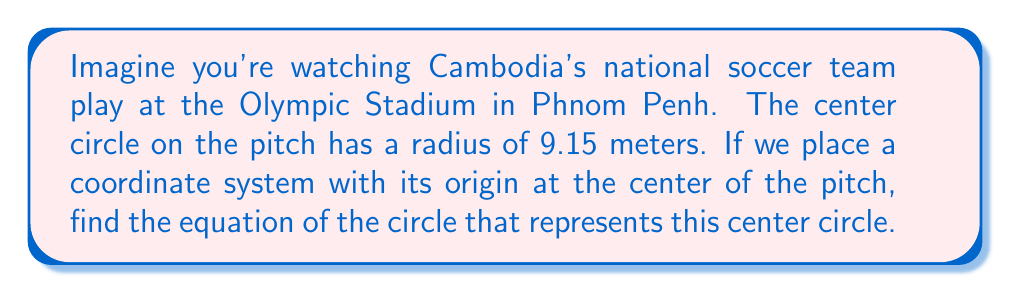What is the answer to this math problem? Let's approach this step-by-step:

1) The general equation of a circle is:

   $$(x - h)^2 + (y - k)^2 = r^2$$

   where $(h, k)$ is the center of the circle and $r$ is the radius.

2) In this case:
   - The center of the circle is at the origin (0, 0), so $h = 0$ and $k = 0$
   - The radius is 9.15 meters

3) Substituting these values into the general equation:

   $$(x - 0)^2 + (y - 0)^2 = 9.15^2$$

4) Simplifying:

   $$x^2 + y^2 = 9.15^2$$

5) Calculate $9.15^2$:

   $$x^2 + y^2 = 83.7225$$

Therefore, the equation of the circle representing the center circle on the soccer pitch is $x^2 + y^2 = 83.7225$.

[asy]
unitsize(10);
draw(circle((0,0),9.15), rgb(0,0,1));
draw((-10,0)--(10,0), arrow=Arrow());
draw((0,-10)--(0,10), arrow=Arrow());
label("x", (10,0), E);
label("y", (0,10), N);
label("9.15 m", (4.575,0), S);
dot((0,0));
[/asy]
Answer: $x^2 + y^2 = 83.7225$ 